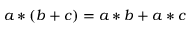<formula> <loc_0><loc_0><loc_500><loc_500>a * ( b + c ) = a * b + a * c</formula> 